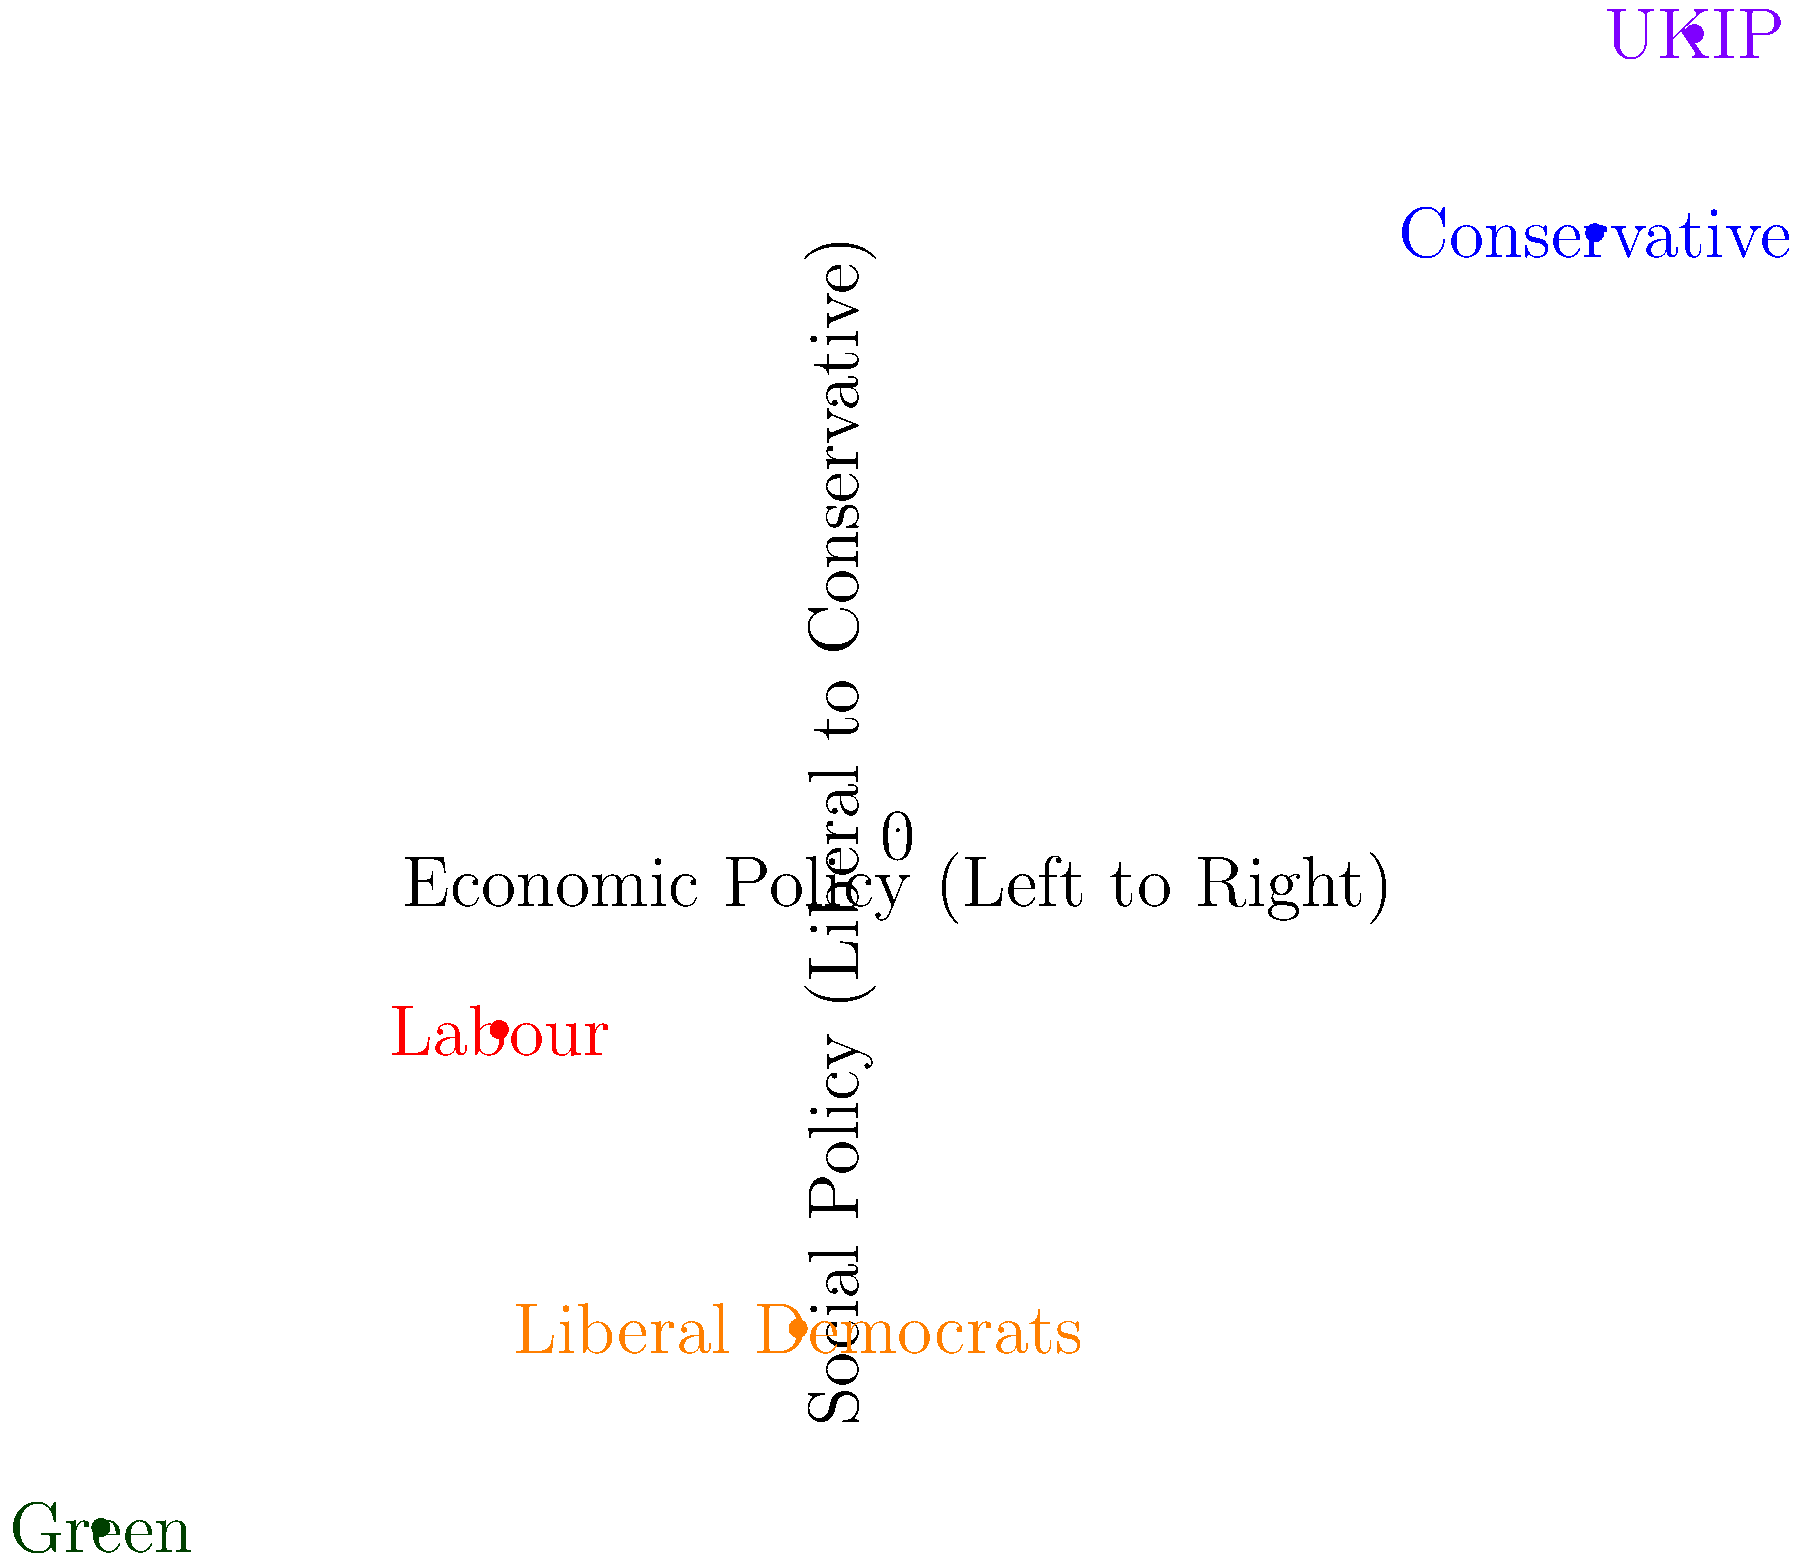Based on the 2D spectrum diagram of UK political parties' ideological positions, which party is positioned furthest to the economic right and most socially conservative? To answer this question, we need to analyze the positions of the parties on the 2D spectrum:

1. The x-axis represents economic policy, with right-wing positions towards the right.
2. The y-axis represents social policy, with conservative positions towards the top.

Let's examine each party's position:

1. Conservative Party: (0.7, 0.6) - Right-leaning economically, somewhat conservative socially.
2. Labour Party: (-0.4, -0.2) - Left-leaning economically, slightly liberal socially.
3. Liberal Democrats: (-0.1, -0.5) - Centrist economically, liberal socially.
4. Green Party: (-0.8, -0.7) - Far-left economically, very liberal socially.
5. UKIP: (0.8, 0.8) - Far-right economically, very conservative socially.

Comparing these positions, we can see that UKIP is positioned furthest to the right on the economic axis (0.8) and highest on the social conservative axis (0.8).
Answer: UKIP 